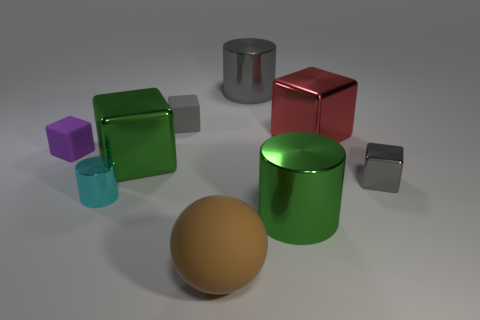What color is the other rubber thing that is the same shape as the purple rubber thing?
Your answer should be very brief. Gray. What number of small cylinders have the same color as the matte sphere?
Offer a very short reply. 0. There is a small metal block; does it have the same color as the shiny cylinder behind the gray rubber block?
Keep it short and to the point. Yes. There is a gray thing that is both behind the small purple rubber block and in front of the gray cylinder; what is its shape?
Ensure brevity in your answer.  Cube. What material is the green object on the right side of the cylinder that is behind the tiny gray thing in front of the purple cube?
Offer a terse response. Metal. Are there more small gray blocks that are in front of the tiny gray metallic thing than big green metal things that are in front of the cyan object?
Ensure brevity in your answer.  No. How many large green blocks are made of the same material as the red block?
Ensure brevity in your answer.  1. Does the green metallic thing that is right of the big rubber sphere have the same shape as the matte object that is right of the gray matte thing?
Offer a very short reply. No. There is a metallic cylinder that is to the left of the brown sphere; what is its color?
Your answer should be very brief. Cyan. Are there any tiny purple things of the same shape as the gray matte thing?
Ensure brevity in your answer.  Yes. 